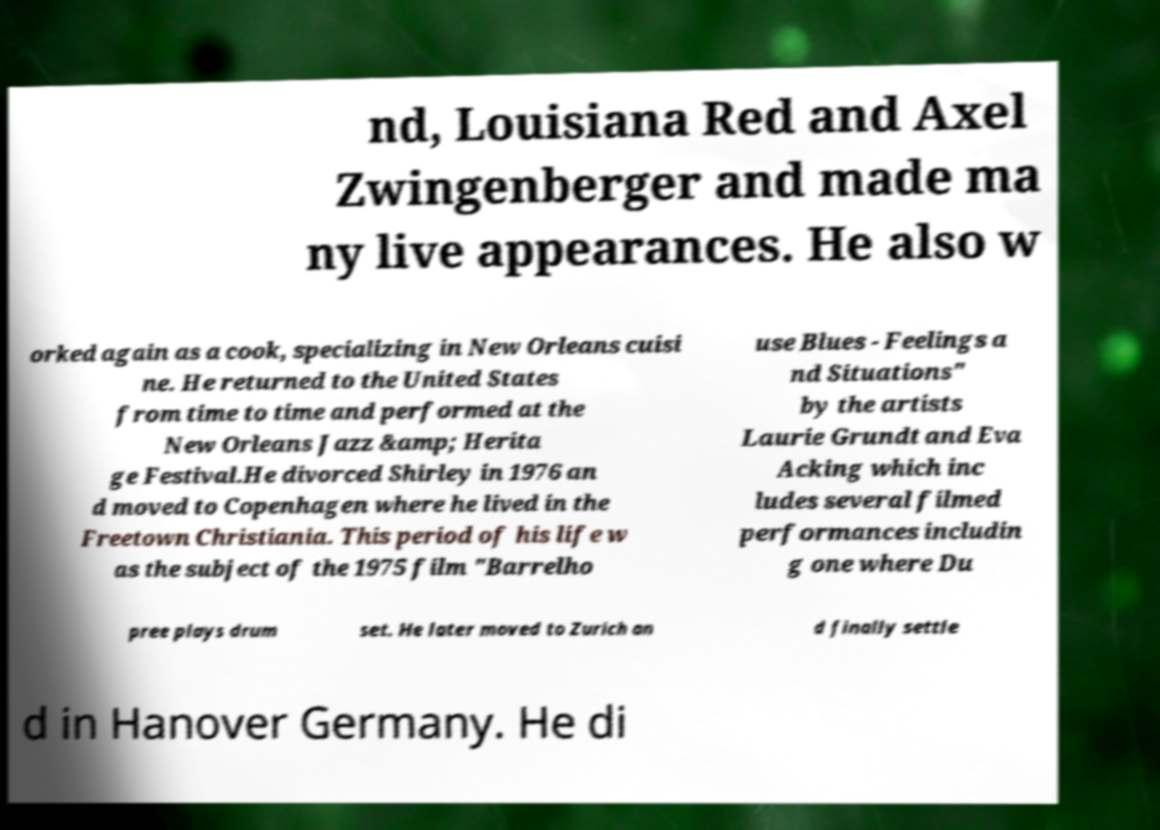I need the written content from this picture converted into text. Can you do that? nd, Louisiana Red and Axel Zwingenberger and made ma ny live appearances. He also w orked again as a cook, specializing in New Orleans cuisi ne. He returned to the United States from time to time and performed at the New Orleans Jazz &amp; Herita ge Festival.He divorced Shirley in 1976 an d moved to Copenhagen where he lived in the Freetown Christiania. This period of his life w as the subject of the 1975 film "Barrelho use Blues - Feelings a nd Situations" by the artists Laurie Grundt and Eva Acking which inc ludes several filmed performances includin g one where Du pree plays drum set. He later moved to Zurich an d finally settle d in Hanover Germany. He di 